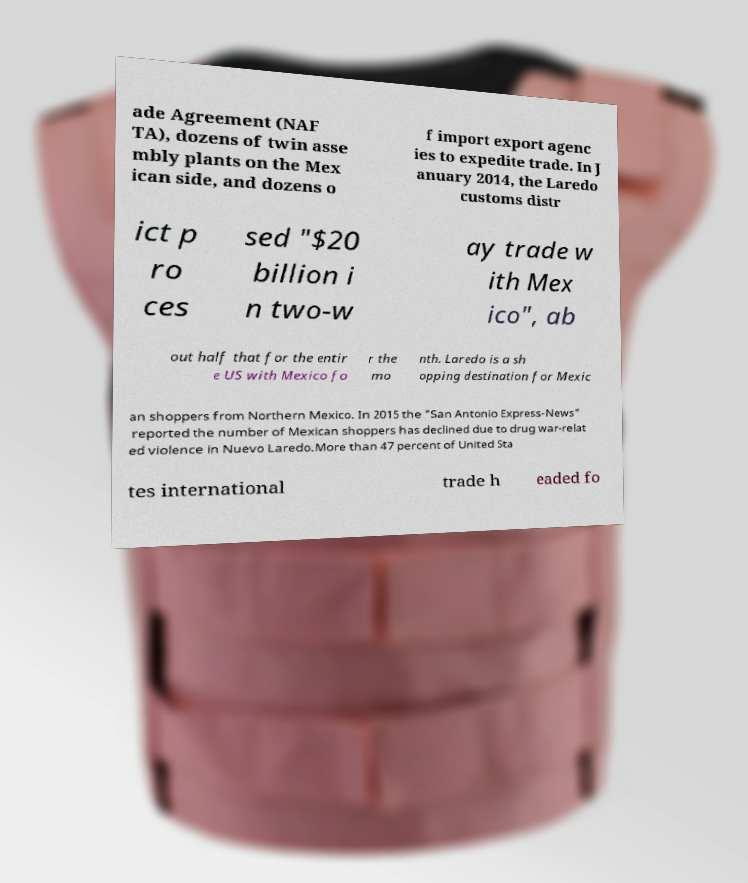For documentation purposes, I need the text within this image transcribed. Could you provide that? ade Agreement (NAF TA), dozens of twin asse mbly plants on the Mex ican side, and dozens o f import export agenc ies to expedite trade. In J anuary 2014, the Laredo customs distr ict p ro ces sed "$20 billion i n two-w ay trade w ith Mex ico", ab out half that for the entir e US with Mexico fo r the mo nth. Laredo is a sh opping destination for Mexic an shoppers from Northern Mexico. In 2015 the "San Antonio Express-News" reported the number of Mexican shoppers has declined due to drug war-relat ed violence in Nuevo Laredo.More than 47 percent of United Sta tes international trade h eaded fo 